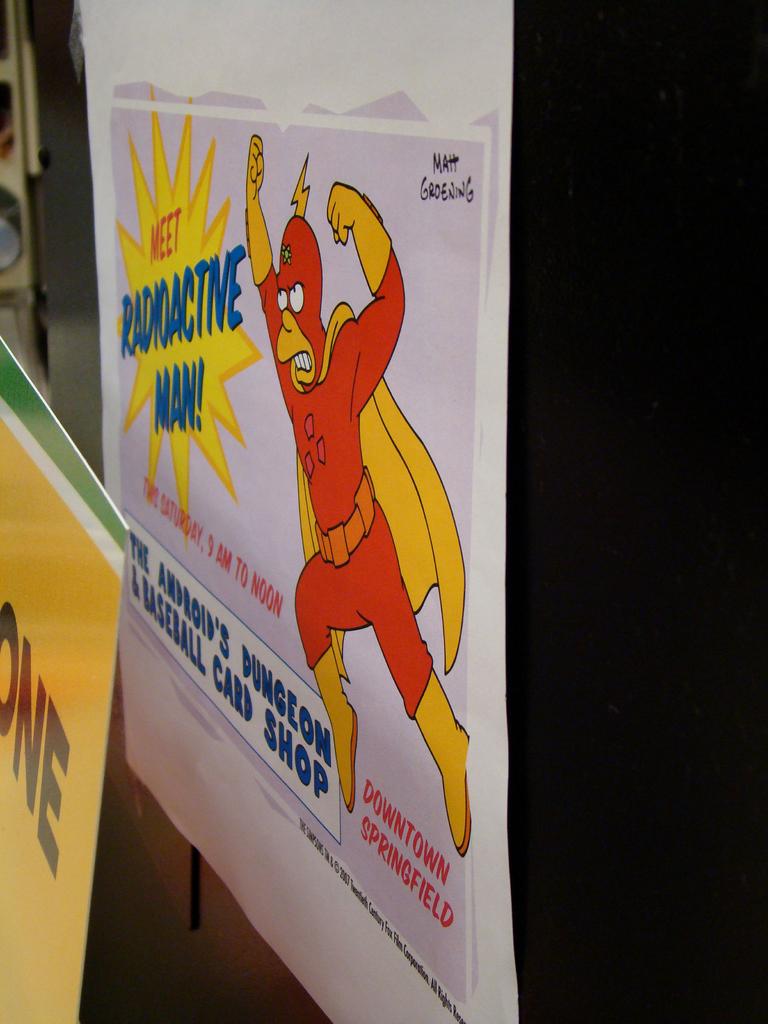What type of man is that?
Ensure brevity in your answer.  Radioactive man. What type of shop is that?
Ensure brevity in your answer.  Baseball card. 